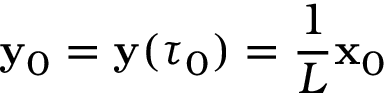Convert formula to latex. <formula><loc_0><loc_0><loc_500><loc_500>{ \mathbf y } _ { 0 } = { \mathbf y } ( \tau _ { 0 } ) = \frac { 1 } { L } { \mathbf x } _ { 0 }</formula> 